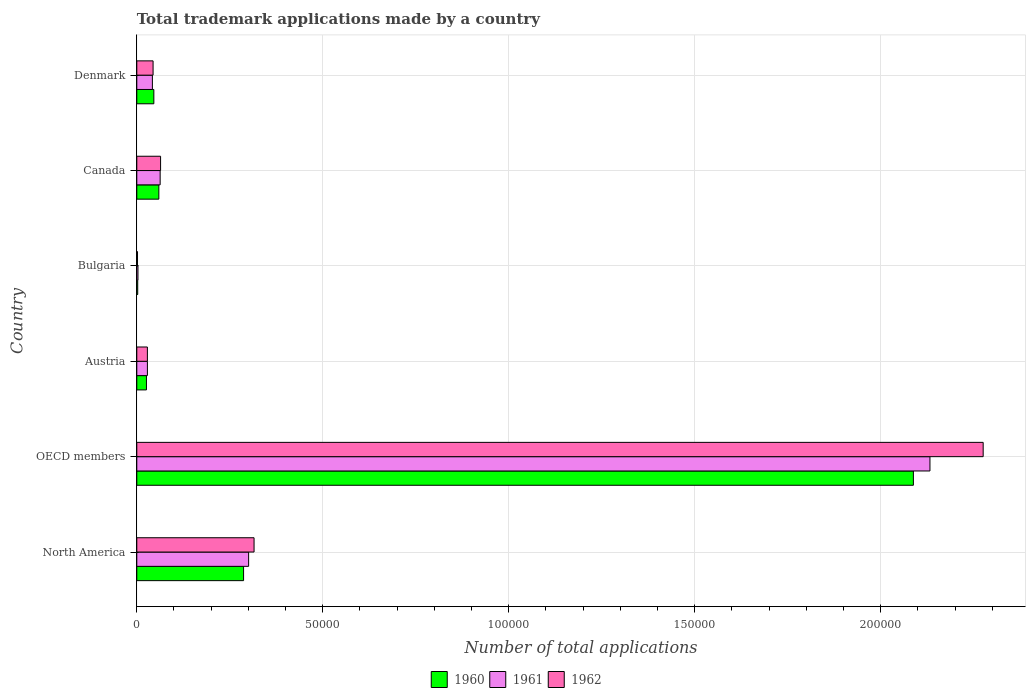How many groups of bars are there?
Your response must be concise. 6. Are the number of bars per tick equal to the number of legend labels?
Your answer should be compact. Yes. How many bars are there on the 6th tick from the bottom?
Ensure brevity in your answer.  3. What is the label of the 1st group of bars from the top?
Offer a very short reply. Denmark. What is the number of applications made by in 1960 in Bulgaria?
Give a very brief answer. 250. Across all countries, what is the maximum number of applications made by in 1961?
Keep it short and to the point. 2.13e+05. Across all countries, what is the minimum number of applications made by in 1961?
Keep it short and to the point. 318. In which country was the number of applications made by in 1962 maximum?
Make the answer very short. OECD members. In which country was the number of applications made by in 1962 minimum?
Your answer should be very brief. Bulgaria. What is the total number of applications made by in 1960 in the graph?
Provide a succinct answer. 2.51e+05. What is the difference between the number of applications made by in 1962 in Denmark and that in North America?
Provide a short and direct response. -2.71e+04. What is the difference between the number of applications made by in 1960 in Denmark and the number of applications made by in 1962 in North America?
Your answer should be compact. -2.69e+04. What is the average number of applications made by in 1961 per country?
Provide a short and direct response. 4.28e+04. What is the difference between the number of applications made by in 1962 and number of applications made by in 1960 in North America?
Offer a very short reply. 2817. In how many countries, is the number of applications made by in 1960 greater than 180000 ?
Keep it short and to the point. 1. What is the ratio of the number of applications made by in 1961 in Austria to that in North America?
Provide a succinct answer. 0.09. Is the difference between the number of applications made by in 1962 in North America and OECD members greater than the difference between the number of applications made by in 1960 in North America and OECD members?
Give a very brief answer. No. What is the difference between the highest and the second highest number of applications made by in 1961?
Give a very brief answer. 1.83e+05. What is the difference between the highest and the lowest number of applications made by in 1960?
Provide a succinct answer. 2.09e+05. Is the sum of the number of applications made by in 1961 in Bulgaria and Denmark greater than the maximum number of applications made by in 1962 across all countries?
Offer a terse response. No. What does the 3rd bar from the top in Austria represents?
Make the answer very short. 1960. What does the 1st bar from the bottom in Austria represents?
Make the answer very short. 1960. How many countries are there in the graph?
Ensure brevity in your answer.  6. What is the difference between two consecutive major ticks on the X-axis?
Give a very brief answer. 5.00e+04. Does the graph contain any zero values?
Offer a terse response. No. Does the graph contain grids?
Provide a short and direct response. Yes. How are the legend labels stacked?
Provide a short and direct response. Horizontal. What is the title of the graph?
Your answer should be compact. Total trademark applications made by a country. Does "2010" appear as one of the legend labels in the graph?
Offer a very short reply. No. What is the label or title of the X-axis?
Give a very brief answer. Number of total applications. What is the Number of total applications in 1960 in North America?
Offer a very short reply. 2.87e+04. What is the Number of total applications of 1961 in North America?
Your answer should be very brief. 3.01e+04. What is the Number of total applications of 1962 in North America?
Offer a terse response. 3.15e+04. What is the Number of total applications in 1960 in OECD members?
Your answer should be very brief. 2.09e+05. What is the Number of total applications of 1961 in OECD members?
Your answer should be compact. 2.13e+05. What is the Number of total applications in 1962 in OECD members?
Make the answer very short. 2.28e+05. What is the Number of total applications in 1960 in Austria?
Offer a terse response. 2596. What is the Number of total applications of 1961 in Austria?
Offer a very short reply. 2852. What is the Number of total applications of 1962 in Austria?
Your answer should be compact. 2849. What is the Number of total applications of 1960 in Bulgaria?
Provide a succinct answer. 250. What is the Number of total applications of 1961 in Bulgaria?
Offer a terse response. 318. What is the Number of total applications in 1962 in Bulgaria?
Offer a very short reply. 195. What is the Number of total applications in 1960 in Canada?
Offer a terse response. 5927. What is the Number of total applications in 1961 in Canada?
Your answer should be compact. 6281. What is the Number of total applications in 1962 in Canada?
Provide a short and direct response. 6395. What is the Number of total applications of 1960 in Denmark?
Make the answer very short. 4584. What is the Number of total applications of 1961 in Denmark?
Your response must be concise. 4196. What is the Number of total applications in 1962 in Denmark?
Give a very brief answer. 4380. Across all countries, what is the maximum Number of total applications of 1960?
Keep it short and to the point. 2.09e+05. Across all countries, what is the maximum Number of total applications of 1961?
Make the answer very short. 2.13e+05. Across all countries, what is the maximum Number of total applications of 1962?
Provide a succinct answer. 2.28e+05. Across all countries, what is the minimum Number of total applications of 1960?
Offer a very short reply. 250. Across all countries, what is the minimum Number of total applications in 1961?
Offer a very short reply. 318. Across all countries, what is the minimum Number of total applications of 1962?
Your answer should be very brief. 195. What is the total Number of total applications in 1960 in the graph?
Ensure brevity in your answer.  2.51e+05. What is the total Number of total applications in 1961 in the graph?
Your answer should be very brief. 2.57e+05. What is the total Number of total applications in 1962 in the graph?
Offer a terse response. 2.73e+05. What is the difference between the Number of total applications in 1960 in North America and that in OECD members?
Offer a terse response. -1.80e+05. What is the difference between the Number of total applications of 1961 in North America and that in OECD members?
Keep it short and to the point. -1.83e+05. What is the difference between the Number of total applications in 1962 in North America and that in OECD members?
Keep it short and to the point. -1.96e+05. What is the difference between the Number of total applications in 1960 in North America and that in Austria?
Keep it short and to the point. 2.61e+04. What is the difference between the Number of total applications of 1961 in North America and that in Austria?
Give a very brief answer. 2.72e+04. What is the difference between the Number of total applications of 1962 in North America and that in Austria?
Offer a terse response. 2.87e+04. What is the difference between the Number of total applications of 1960 in North America and that in Bulgaria?
Your answer should be compact. 2.85e+04. What is the difference between the Number of total applications in 1961 in North America and that in Bulgaria?
Ensure brevity in your answer.  2.97e+04. What is the difference between the Number of total applications of 1962 in North America and that in Bulgaria?
Make the answer very short. 3.13e+04. What is the difference between the Number of total applications of 1960 in North America and that in Canada?
Ensure brevity in your answer.  2.28e+04. What is the difference between the Number of total applications in 1961 in North America and that in Canada?
Your response must be concise. 2.38e+04. What is the difference between the Number of total applications in 1962 in North America and that in Canada?
Ensure brevity in your answer.  2.51e+04. What is the difference between the Number of total applications in 1960 in North America and that in Denmark?
Provide a succinct answer. 2.41e+04. What is the difference between the Number of total applications in 1961 in North America and that in Denmark?
Your answer should be compact. 2.59e+04. What is the difference between the Number of total applications of 1962 in North America and that in Denmark?
Give a very brief answer. 2.71e+04. What is the difference between the Number of total applications in 1960 in OECD members and that in Austria?
Keep it short and to the point. 2.06e+05. What is the difference between the Number of total applications of 1961 in OECD members and that in Austria?
Provide a succinct answer. 2.10e+05. What is the difference between the Number of total applications of 1962 in OECD members and that in Austria?
Ensure brevity in your answer.  2.25e+05. What is the difference between the Number of total applications in 1960 in OECD members and that in Bulgaria?
Your answer should be very brief. 2.09e+05. What is the difference between the Number of total applications in 1961 in OECD members and that in Bulgaria?
Offer a very short reply. 2.13e+05. What is the difference between the Number of total applications in 1962 in OECD members and that in Bulgaria?
Your answer should be very brief. 2.27e+05. What is the difference between the Number of total applications of 1960 in OECD members and that in Canada?
Your answer should be compact. 2.03e+05. What is the difference between the Number of total applications of 1961 in OECD members and that in Canada?
Your response must be concise. 2.07e+05. What is the difference between the Number of total applications of 1962 in OECD members and that in Canada?
Make the answer very short. 2.21e+05. What is the difference between the Number of total applications in 1960 in OECD members and that in Denmark?
Offer a very short reply. 2.04e+05. What is the difference between the Number of total applications in 1961 in OECD members and that in Denmark?
Provide a succinct answer. 2.09e+05. What is the difference between the Number of total applications in 1962 in OECD members and that in Denmark?
Provide a short and direct response. 2.23e+05. What is the difference between the Number of total applications in 1960 in Austria and that in Bulgaria?
Keep it short and to the point. 2346. What is the difference between the Number of total applications of 1961 in Austria and that in Bulgaria?
Offer a very short reply. 2534. What is the difference between the Number of total applications of 1962 in Austria and that in Bulgaria?
Offer a terse response. 2654. What is the difference between the Number of total applications in 1960 in Austria and that in Canada?
Your answer should be compact. -3331. What is the difference between the Number of total applications in 1961 in Austria and that in Canada?
Your response must be concise. -3429. What is the difference between the Number of total applications in 1962 in Austria and that in Canada?
Offer a very short reply. -3546. What is the difference between the Number of total applications of 1960 in Austria and that in Denmark?
Provide a succinct answer. -1988. What is the difference between the Number of total applications in 1961 in Austria and that in Denmark?
Keep it short and to the point. -1344. What is the difference between the Number of total applications in 1962 in Austria and that in Denmark?
Your response must be concise. -1531. What is the difference between the Number of total applications of 1960 in Bulgaria and that in Canada?
Offer a very short reply. -5677. What is the difference between the Number of total applications in 1961 in Bulgaria and that in Canada?
Your answer should be very brief. -5963. What is the difference between the Number of total applications in 1962 in Bulgaria and that in Canada?
Provide a succinct answer. -6200. What is the difference between the Number of total applications in 1960 in Bulgaria and that in Denmark?
Your response must be concise. -4334. What is the difference between the Number of total applications in 1961 in Bulgaria and that in Denmark?
Provide a succinct answer. -3878. What is the difference between the Number of total applications of 1962 in Bulgaria and that in Denmark?
Your response must be concise. -4185. What is the difference between the Number of total applications of 1960 in Canada and that in Denmark?
Provide a succinct answer. 1343. What is the difference between the Number of total applications of 1961 in Canada and that in Denmark?
Offer a very short reply. 2085. What is the difference between the Number of total applications of 1962 in Canada and that in Denmark?
Provide a short and direct response. 2015. What is the difference between the Number of total applications of 1960 in North America and the Number of total applications of 1961 in OECD members?
Your response must be concise. -1.85e+05. What is the difference between the Number of total applications in 1960 in North America and the Number of total applications in 1962 in OECD members?
Your response must be concise. -1.99e+05. What is the difference between the Number of total applications of 1961 in North America and the Number of total applications of 1962 in OECD members?
Provide a succinct answer. -1.97e+05. What is the difference between the Number of total applications in 1960 in North America and the Number of total applications in 1961 in Austria?
Your response must be concise. 2.59e+04. What is the difference between the Number of total applications of 1960 in North America and the Number of total applications of 1962 in Austria?
Provide a succinct answer. 2.59e+04. What is the difference between the Number of total applications of 1961 in North America and the Number of total applications of 1962 in Austria?
Your answer should be very brief. 2.72e+04. What is the difference between the Number of total applications in 1960 in North America and the Number of total applications in 1961 in Bulgaria?
Offer a terse response. 2.84e+04. What is the difference between the Number of total applications of 1960 in North America and the Number of total applications of 1962 in Bulgaria?
Provide a short and direct response. 2.85e+04. What is the difference between the Number of total applications of 1961 in North America and the Number of total applications of 1962 in Bulgaria?
Provide a succinct answer. 2.99e+04. What is the difference between the Number of total applications of 1960 in North America and the Number of total applications of 1961 in Canada?
Your answer should be compact. 2.24e+04. What is the difference between the Number of total applications in 1960 in North America and the Number of total applications in 1962 in Canada?
Your response must be concise. 2.23e+04. What is the difference between the Number of total applications in 1961 in North America and the Number of total applications in 1962 in Canada?
Make the answer very short. 2.37e+04. What is the difference between the Number of total applications of 1960 in North America and the Number of total applications of 1961 in Denmark?
Keep it short and to the point. 2.45e+04. What is the difference between the Number of total applications in 1960 in North America and the Number of total applications in 1962 in Denmark?
Provide a succinct answer. 2.43e+04. What is the difference between the Number of total applications of 1961 in North America and the Number of total applications of 1962 in Denmark?
Provide a succinct answer. 2.57e+04. What is the difference between the Number of total applications of 1960 in OECD members and the Number of total applications of 1961 in Austria?
Make the answer very short. 2.06e+05. What is the difference between the Number of total applications in 1960 in OECD members and the Number of total applications in 1962 in Austria?
Your answer should be compact. 2.06e+05. What is the difference between the Number of total applications in 1961 in OECD members and the Number of total applications in 1962 in Austria?
Make the answer very short. 2.10e+05. What is the difference between the Number of total applications in 1960 in OECD members and the Number of total applications in 1961 in Bulgaria?
Your response must be concise. 2.08e+05. What is the difference between the Number of total applications of 1960 in OECD members and the Number of total applications of 1962 in Bulgaria?
Make the answer very short. 2.09e+05. What is the difference between the Number of total applications of 1961 in OECD members and the Number of total applications of 1962 in Bulgaria?
Offer a very short reply. 2.13e+05. What is the difference between the Number of total applications of 1960 in OECD members and the Number of total applications of 1961 in Canada?
Keep it short and to the point. 2.02e+05. What is the difference between the Number of total applications in 1960 in OECD members and the Number of total applications in 1962 in Canada?
Keep it short and to the point. 2.02e+05. What is the difference between the Number of total applications of 1961 in OECD members and the Number of total applications of 1962 in Canada?
Ensure brevity in your answer.  2.07e+05. What is the difference between the Number of total applications in 1960 in OECD members and the Number of total applications in 1961 in Denmark?
Provide a short and direct response. 2.05e+05. What is the difference between the Number of total applications of 1960 in OECD members and the Number of total applications of 1962 in Denmark?
Provide a short and direct response. 2.04e+05. What is the difference between the Number of total applications of 1961 in OECD members and the Number of total applications of 1962 in Denmark?
Make the answer very short. 2.09e+05. What is the difference between the Number of total applications of 1960 in Austria and the Number of total applications of 1961 in Bulgaria?
Offer a terse response. 2278. What is the difference between the Number of total applications of 1960 in Austria and the Number of total applications of 1962 in Bulgaria?
Make the answer very short. 2401. What is the difference between the Number of total applications in 1961 in Austria and the Number of total applications in 1962 in Bulgaria?
Ensure brevity in your answer.  2657. What is the difference between the Number of total applications of 1960 in Austria and the Number of total applications of 1961 in Canada?
Your response must be concise. -3685. What is the difference between the Number of total applications of 1960 in Austria and the Number of total applications of 1962 in Canada?
Ensure brevity in your answer.  -3799. What is the difference between the Number of total applications in 1961 in Austria and the Number of total applications in 1962 in Canada?
Offer a terse response. -3543. What is the difference between the Number of total applications of 1960 in Austria and the Number of total applications of 1961 in Denmark?
Your answer should be very brief. -1600. What is the difference between the Number of total applications of 1960 in Austria and the Number of total applications of 1962 in Denmark?
Provide a short and direct response. -1784. What is the difference between the Number of total applications of 1961 in Austria and the Number of total applications of 1962 in Denmark?
Give a very brief answer. -1528. What is the difference between the Number of total applications of 1960 in Bulgaria and the Number of total applications of 1961 in Canada?
Ensure brevity in your answer.  -6031. What is the difference between the Number of total applications of 1960 in Bulgaria and the Number of total applications of 1962 in Canada?
Your response must be concise. -6145. What is the difference between the Number of total applications in 1961 in Bulgaria and the Number of total applications in 1962 in Canada?
Offer a terse response. -6077. What is the difference between the Number of total applications of 1960 in Bulgaria and the Number of total applications of 1961 in Denmark?
Make the answer very short. -3946. What is the difference between the Number of total applications in 1960 in Bulgaria and the Number of total applications in 1962 in Denmark?
Offer a very short reply. -4130. What is the difference between the Number of total applications of 1961 in Bulgaria and the Number of total applications of 1962 in Denmark?
Make the answer very short. -4062. What is the difference between the Number of total applications in 1960 in Canada and the Number of total applications in 1961 in Denmark?
Your answer should be very brief. 1731. What is the difference between the Number of total applications in 1960 in Canada and the Number of total applications in 1962 in Denmark?
Provide a short and direct response. 1547. What is the difference between the Number of total applications in 1961 in Canada and the Number of total applications in 1962 in Denmark?
Give a very brief answer. 1901. What is the average Number of total applications in 1960 per country?
Your answer should be compact. 4.18e+04. What is the average Number of total applications in 1961 per country?
Your answer should be very brief. 4.28e+04. What is the average Number of total applications in 1962 per country?
Make the answer very short. 4.55e+04. What is the difference between the Number of total applications of 1960 and Number of total applications of 1961 in North America?
Your response must be concise. -1355. What is the difference between the Number of total applications of 1960 and Number of total applications of 1962 in North America?
Make the answer very short. -2817. What is the difference between the Number of total applications of 1961 and Number of total applications of 1962 in North America?
Provide a succinct answer. -1462. What is the difference between the Number of total applications of 1960 and Number of total applications of 1961 in OECD members?
Your answer should be compact. -4452. What is the difference between the Number of total applications of 1960 and Number of total applications of 1962 in OECD members?
Keep it short and to the point. -1.88e+04. What is the difference between the Number of total applications of 1961 and Number of total applications of 1962 in OECD members?
Ensure brevity in your answer.  -1.43e+04. What is the difference between the Number of total applications in 1960 and Number of total applications in 1961 in Austria?
Provide a succinct answer. -256. What is the difference between the Number of total applications in 1960 and Number of total applications in 1962 in Austria?
Offer a very short reply. -253. What is the difference between the Number of total applications of 1961 and Number of total applications of 1962 in Austria?
Your answer should be compact. 3. What is the difference between the Number of total applications in 1960 and Number of total applications in 1961 in Bulgaria?
Your response must be concise. -68. What is the difference between the Number of total applications in 1961 and Number of total applications in 1962 in Bulgaria?
Ensure brevity in your answer.  123. What is the difference between the Number of total applications in 1960 and Number of total applications in 1961 in Canada?
Provide a succinct answer. -354. What is the difference between the Number of total applications in 1960 and Number of total applications in 1962 in Canada?
Your answer should be compact. -468. What is the difference between the Number of total applications in 1961 and Number of total applications in 1962 in Canada?
Offer a very short reply. -114. What is the difference between the Number of total applications in 1960 and Number of total applications in 1961 in Denmark?
Provide a short and direct response. 388. What is the difference between the Number of total applications in 1960 and Number of total applications in 1962 in Denmark?
Keep it short and to the point. 204. What is the difference between the Number of total applications of 1961 and Number of total applications of 1962 in Denmark?
Provide a short and direct response. -184. What is the ratio of the Number of total applications in 1960 in North America to that in OECD members?
Offer a terse response. 0.14. What is the ratio of the Number of total applications of 1961 in North America to that in OECD members?
Provide a succinct answer. 0.14. What is the ratio of the Number of total applications of 1962 in North America to that in OECD members?
Your answer should be very brief. 0.14. What is the ratio of the Number of total applications of 1960 in North America to that in Austria?
Offer a terse response. 11.06. What is the ratio of the Number of total applications in 1961 in North America to that in Austria?
Offer a very short reply. 10.54. What is the ratio of the Number of total applications in 1962 in North America to that in Austria?
Your answer should be compact. 11.07. What is the ratio of the Number of total applications in 1960 in North America to that in Bulgaria?
Your response must be concise. 114.83. What is the ratio of the Number of total applications in 1961 in North America to that in Bulgaria?
Give a very brief answer. 94.54. What is the ratio of the Number of total applications in 1962 in North America to that in Bulgaria?
Keep it short and to the point. 161.67. What is the ratio of the Number of total applications of 1960 in North America to that in Canada?
Your answer should be compact. 4.84. What is the ratio of the Number of total applications in 1961 in North America to that in Canada?
Your answer should be very brief. 4.79. What is the ratio of the Number of total applications in 1962 in North America to that in Canada?
Offer a terse response. 4.93. What is the ratio of the Number of total applications of 1960 in North America to that in Denmark?
Keep it short and to the point. 6.26. What is the ratio of the Number of total applications of 1961 in North America to that in Denmark?
Your answer should be very brief. 7.16. What is the ratio of the Number of total applications in 1962 in North America to that in Denmark?
Offer a very short reply. 7.2. What is the ratio of the Number of total applications in 1960 in OECD members to that in Austria?
Provide a short and direct response. 80.42. What is the ratio of the Number of total applications in 1961 in OECD members to that in Austria?
Ensure brevity in your answer.  74.76. What is the ratio of the Number of total applications in 1962 in OECD members to that in Austria?
Your response must be concise. 79.86. What is the ratio of the Number of total applications in 1960 in OECD members to that in Bulgaria?
Provide a succinct answer. 835.08. What is the ratio of the Number of total applications of 1961 in OECD members to that in Bulgaria?
Your answer should be very brief. 670.51. What is the ratio of the Number of total applications of 1962 in OECD members to that in Bulgaria?
Make the answer very short. 1166.82. What is the ratio of the Number of total applications of 1960 in OECD members to that in Canada?
Your answer should be very brief. 35.22. What is the ratio of the Number of total applications of 1961 in OECD members to that in Canada?
Offer a very short reply. 33.95. What is the ratio of the Number of total applications in 1962 in OECD members to that in Canada?
Your response must be concise. 35.58. What is the ratio of the Number of total applications of 1960 in OECD members to that in Denmark?
Provide a succinct answer. 45.54. What is the ratio of the Number of total applications in 1961 in OECD members to that in Denmark?
Your response must be concise. 50.82. What is the ratio of the Number of total applications in 1962 in OECD members to that in Denmark?
Your answer should be very brief. 51.95. What is the ratio of the Number of total applications of 1960 in Austria to that in Bulgaria?
Your response must be concise. 10.38. What is the ratio of the Number of total applications in 1961 in Austria to that in Bulgaria?
Provide a succinct answer. 8.97. What is the ratio of the Number of total applications of 1962 in Austria to that in Bulgaria?
Offer a terse response. 14.61. What is the ratio of the Number of total applications of 1960 in Austria to that in Canada?
Your answer should be very brief. 0.44. What is the ratio of the Number of total applications in 1961 in Austria to that in Canada?
Provide a succinct answer. 0.45. What is the ratio of the Number of total applications in 1962 in Austria to that in Canada?
Give a very brief answer. 0.45. What is the ratio of the Number of total applications in 1960 in Austria to that in Denmark?
Give a very brief answer. 0.57. What is the ratio of the Number of total applications in 1961 in Austria to that in Denmark?
Offer a terse response. 0.68. What is the ratio of the Number of total applications of 1962 in Austria to that in Denmark?
Your answer should be compact. 0.65. What is the ratio of the Number of total applications in 1960 in Bulgaria to that in Canada?
Offer a terse response. 0.04. What is the ratio of the Number of total applications of 1961 in Bulgaria to that in Canada?
Make the answer very short. 0.05. What is the ratio of the Number of total applications of 1962 in Bulgaria to that in Canada?
Offer a very short reply. 0.03. What is the ratio of the Number of total applications in 1960 in Bulgaria to that in Denmark?
Offer a terse response. 0.05. What is the ratio of the Number of total applications in 1961 in Bulgaria to that in Denmark?
Offer a very short reply. 0.08. What is the ratio of the Number of total applications of 1962 in Bulgaria to that in Denmark?
Offer a very short reply. 0.04. What is the ratio of the Number of total applications in 1960 in Canada to that in Denmark?
Ensure brevity in your answer.  1.29. What is the ratio of the Number of total applications in 1961 in Canada to that in Denmark?
Ensure brevity in your answer.  1.5. What is the ratio of the Number of total applications of 1962 in Canada to that in Denmark?
Make the answer very short. 1.46. What is the difference between the highest and the second highest Number of total applications in 1960?
Make the answer very short. 1.80e+05. What is the difference between the highest and the second highest Number of total applications of 1961?
Provide a succinct answer. 1.83e+05. What is the difference between the highest and the second highest Number of total applications of 1962?
Offer a terse response. 1.96e+05. What is the difference between the highest and the lowest Number of total applications of 1960?
Provide a succinct answer. 2.09e+05. What is the difference between the highest and the lowest Number of total applications of 1961?
Give a very brief answer. 2.13e+05. What is the difference between the highest and the lowest Number of total applications in 1962?
Your answer should be compact. 2.27e+05. 